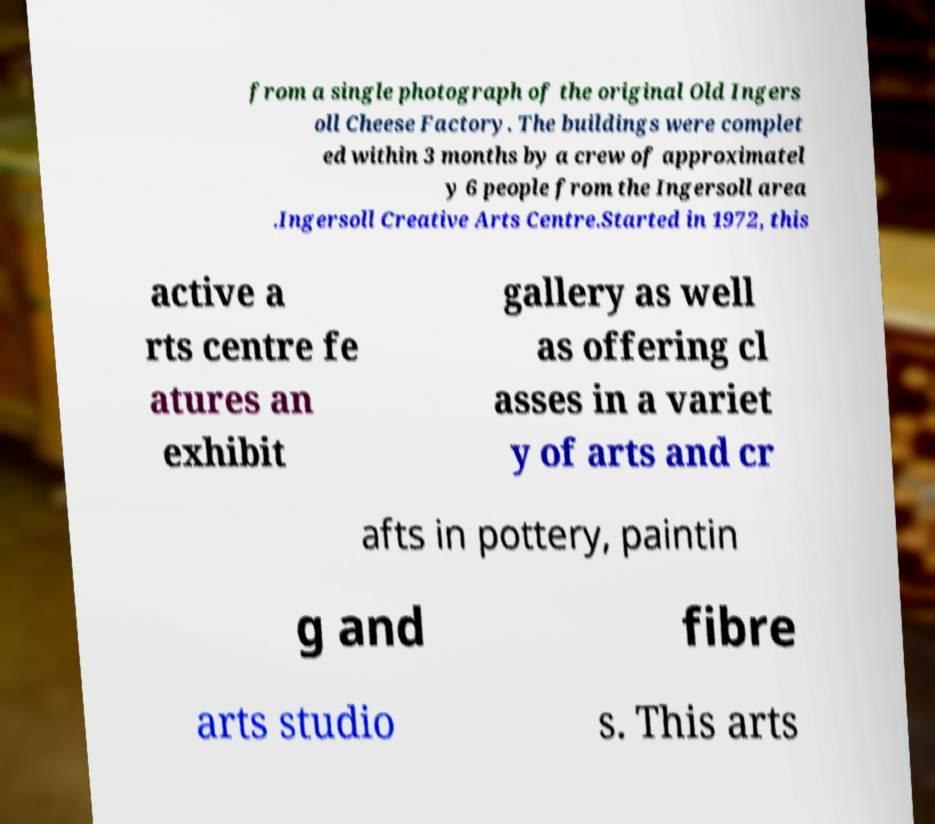Please identify and transcribe the text found in this image. from a single photograph of the original Old Ingers oll Cheese Factory. The buildings were complet ed within 3 months by a crew of approximatel y 6 people from the Ingersoll area .Ingersoll Creative Arts Centre.Started in 1972, this active a rts centre fe atures an exhibit gallery as well as offering cl asses in a variet y of arts and cr afts in pottery, paintin g and fibre arts studio s. This arts 